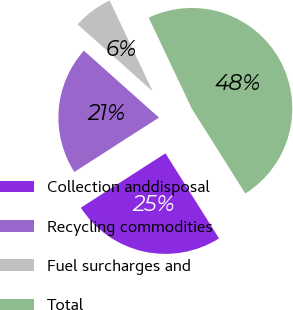Convert chart. <chart><loc_0><loc_0><loc_500><loc_500><pie_chart><fcel>Collection anddisposal<fcel>Recycling commodities<fcel>Fuel surcharges and<fcel>Total<nl><fcel>24.86%<fcel>20.68%<fcel>6.37%<fcel>48.09%<nl></chart> 